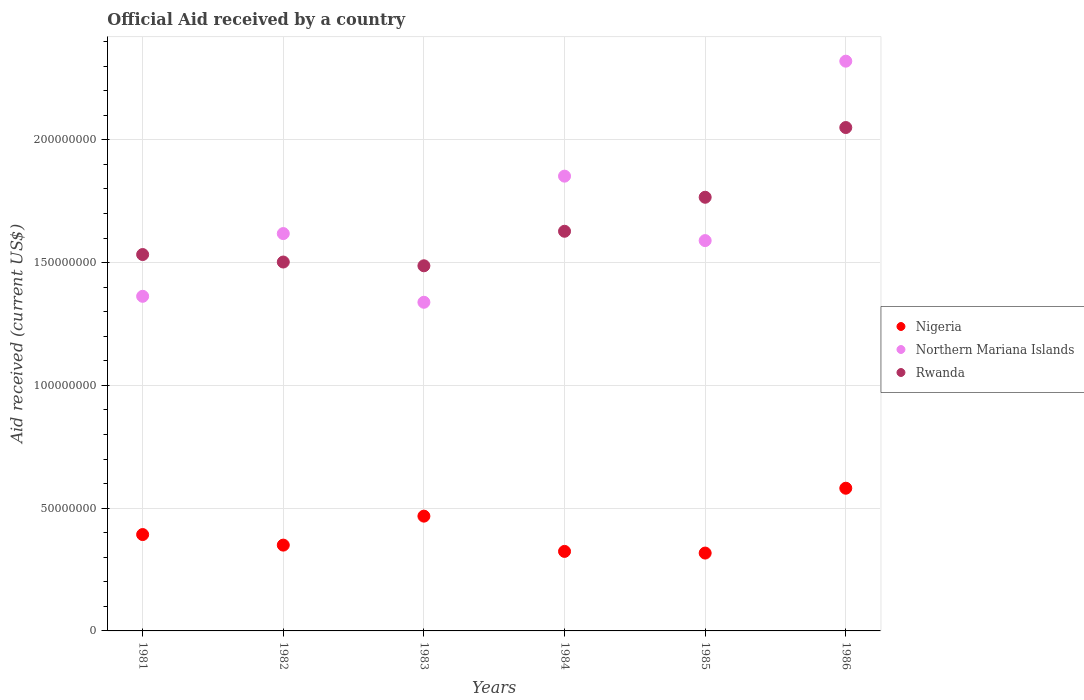Is the number of dotlines equal to the number of legend labels?
Your answer should be very brief. Yes. What is the net official aid received in Rwanda in 1985?
Ensure brevity in your answer.  1.77e+08. Across all years, what is the maximum net official aid received in Northern Mariana Islands?
Ensure brevity in your answer.  2.32e+08. Across all years, what is the minimum net official aid received in Northern Mariana Islands?
Your answer should be very brief. 1.34e+08. In which year was the net official aid received in Northern Mariana Islands minimum?
Your response must be concise. 1983. What is the total net official aid received in Nigeria in the graph?
Offer a terse response. 2.43e+08. What is the difference between the net official aid received in Northern Mariana Islands in 1982 and that in 1983?
Ensure brevity in your answer.  2.80e+07. What is the difference between the net official aid received in Nigeria in 1984 and the net official aid received in Rwanda in 1981?
Offer a terse response. -1.21e+08. What is the average net official aid received in Nigeria per year?
Give a very brief answer. 4.05e+07. In the year 1985, what is the difference between the net official aid received in Nigeria and net official aid received in Rwanda?
Your answer should be compact. -1.45e+08. What is the ratio of the net official aid received in Northern Mariana Islands in 1982 to that in 1983?
Give a very brief answer. 1.21. Is the net official aid received in Northern Mariana Islands in 1981 less than that in 1985?
Your response must be concise. Yes. Is the difference between the net official aid received in Nigeria in 1982 and 1984 greater than the difference between the net official aid received in Rwanda in 1982 and 1984?
Offer a very short reply. Yes. What is the difference between the highest and the second highest net official aid received in Rwanda?
Your response must be concise. 2.84e+07. What is the difference between the highest and the lowest net official aid received in Rwanda?
Keep it short and to the point. 5.63e+07. In how many years, is the net official aid received in Nigeria greater than the average net official aid received in Nigeria taken over all years?
Provide a short and direct response. 2. Is it the case that in every year, the sum of the net official aid received in Rwanda and net official aid received in Northern Mariana Islands  is greater than the net official aid received in Nigeria?
Keep it short and to the point. Yes. Does the net official aid received in Rwanda monotonically increase over the years?
Your answer should be very brief. No. Is the net official aid received in Nigeria strictly less than the net official aid received in Northern Mariana Islands over the years?
Provide a succinct answer. Yes. What is the difference between two consecutive major ticks on the Y-axis?
Offer a terse response. 5.00e+07. Does the graph contain any zero values?
Your answer should be very brief. No. Does the graph contain grids?
Keep it short and to the point. Yes. How many legend labels are there?
Provide a short and direct response. 3. What is the title of the graph?
Provide a succinct answer. Official Aid received by a country. Does "Dominica" appear as one of the legend labels in the graph?
Ensure brevity in your answer.  No. What is the label or title of the Y-axis?
Keep it short and to the point. Aid received (current US$). What is the Aid received (current US$) in Nigeria in 1981?
Make the answer very short. 3.92e+07. What is the Aid received (current US$) in Northern Mariana Islands in 1981?
Your answer should be very brief. 1.36e+08. What is the Aid received (current US$) in Rwanda in 1981?
Your answer should be compact. 1.53e+08. What is the Aid received (current US$) in Nigeria in 1982?
Give a very brief answer. 3.50e+07. What is the Aid received (current US$) of Northern Mariana Islands in 1982?
Offer a terse response. 1.62e+08. What is the Aid received (current US$) of Rwanda in 1982?
Your response must be concise. 1.50e+08. What is the Aid received (current US$) in Nigeria in 1983?
Offer a terse response. 4.68e+07. What is the Aid received (current US$) of Northern Mariana Islands in 1983?
Offer a very short reply. 1.34e+08. What is the Aid received (current US$) in Rwanda in 1983?
Offer a very short reply. 1.49e+08. What is the Aid received (current US$) in Nigeria in 1984?
Offer a terse response. 3.24e+07. What is the Aid received (current US$) in Northern Mariana Islands in 1984?
Ensure brevity in your answer.  1.85e+08. What is the Aid received (current US$) in Rwanda in 1984?
Your answer should be very brief. 1.63e+08. What is the Aid received (current US$) of Nigeria in 1985?
Your answer should be very brief. 3.17e+07. What is the Aid received (current US$) of Northern Mariana Islands in 1985?
Give a very brief answer. 1.59e+08. What is the Aid received (current US$) in Rwanda in 1985?
Your answer should be very brief. 1.77e+08. What is the Aid received (current US$) of Nigeria in 1986?
Your response must be concise. 5.81e+07. What is the Aid received (current US$) of Northern Mariana Islands in 1986?
Offer a terse response. 2.32e+08. What is the Aid received (current US$) in Rwanda in 1986?
Provide a succinct answer. 2.05e+08. Across all years, what is the maximum Aid received (current US$) in Nigeria?
Your response must be concise. 5.81e+07. Across all years, what is the maximum Aid received (current US$) of Northern Mariana Islands?
Offer a very short reply. 2.32e+08. Across all years, what is the maximum Aid received (current US$) in Rwanda?
Give a very brief answer. 2.05e+08. Across all years, what is the minimum Aid received (current US$) in Nigeria?
Give a very brief answer. 3.17e+07. Across all years, what is the minimum Aid received (current US$) of Northern Mariana Islands?
Ensure brevity in your answer.  1.34e+08. Across all years, what is the minimum Aid received (current US$) of Rwanda?
Your answer should be very brief. 1.49e+08. What is the total Aid received (current US$) of Nigeria in the graph?
Ensure brevity in your answer.  2.43e+08. What is the total Aid received (current US$) of Northern Mariana Islands in the graph?
Provide a succinct answer. 1.01e+09. What is the total Aid received (current US$) in Rwanda in the graph?
Provide a short and direct response. 9.97e+08. What is the difference between the Aid received (current US$) in Nigeria in 1981 and that in 1982?
Your answer should be very brief. 4.30e+06. What is the difference between the Aid received (current US$) of Northern Mariana Islands in 1981 and that in 1982?
Your answer should be compact. -2.56e+07. What is the difference between the Aid received (current US$) of Rwanda in 1981 and that in 1982?
Your response must be concise. 3.05e+06. What is the difference between the Aid received (current US$) in Nigeria in 1981 and that in 1983?
Your answer should be very brief. -7.50e+06. What is the difference between the Aid received (current US$) in Northern Mariana Islands in 1981 and that in 1983?
Offer a very short reply. 2.43e+06. What is the difference between the Aid received (current US$) of Rwanda in 1981 and that in 1983?
Ensure brevity in your answer.  4.58e+06. What is the difference between the Aid received (current US$) of Nigeria in 1981 and that in 1984?
Provide a succinct answer. 6.86e+06. What is the difference between the Aid received (current US$) in Northern Mariana Islands in 1981 and that in 1984?
Make the answer very short. -4.89e+07. What is the difference between the Aid received (current US$) in Rwanda in 1981 and that in 1984?
Your answer should be very brief. -9.48e+06. What is the difference between the Aid received (current US$) of Nigeria in 1981 and that in 1985?
Offer a terse response. 7.54e+06. What is the difference between the Aid received (current US$) in Northern Mariana Islands in 1981 and that in 1985?
Provide a short and direct response. -2.27e+07. What is the difference between the Aid received (current US$) in Rwanda in 1981 and that in 1985?
Offer a terse response. -2.33e+07. What is the difference between the Aid received (current US$) of Nigeria in 1981 and that in 1986?
Ensure brevity in your answer.  -1.89e+07. What is the difference between the Aid received (current US$) of Northern Mariana Islands in 1981 and that in 1986?
Provide a succinct answer. -9.58e+07. What is the difference between the Aid received (current US$) of Rwanda in 1981 and that in 1986?
Provide a succinct answer. -5.17e+07. What is the difference between the Aid received (current US$) of Nigeria in 1982 and that in 1983?
Your answer should be very brief. -1.18e+07. What is the difference between the Aid received (current US$) in Northern Mariana Islands in 1982 and that in 1983?
Give a very brief answer. 2.80e+07. What is the difference between the Aid received (current US$) of Rwanda in 1982 and that in 1983?
Provide a short and direct response. 1.53e+06. What is the difference between the Aid received (current US$) of Nigeria in 1982 and that in 1984?
Give a very brief answer. 2.56e+06. What is the difference between the Aid received (current US$) of Northern Mariana Islands in 1982 and that in 1984?
Make the answer very short. -2.34e+07. What is the difference between the Aid received (current US$) of Rwanda in 1982 and that in 1984?
Your response must be concise. -1.25e+07. What is the difference between the Aid received (current US$) in Nigeria in 1982 and that in 1985?
Keep it short and to the point. 3.24e+06. What is the difference between the Aid received (current US$) of Northern Mariana Islands in 1982 and that in 1985?
Offer a terse response. 2.86e+06. What is the difference between the Aid received (current US$) of Rwanda in 1982 and that in 1985?
Provide a succinct answer. -2.64e+07. What is the difference between the Aid received (current US$) in Nigeria in 1982 and that in 1986?
Provide a short and direct response. -2.32e+07. What is the difference between the Aid received (current US$) in Northern Mariana Islands in 1982 and that in 1986?
Provide a short and direct response. -7.02e+07. What is the difference between the Aid received (current US$) in Rwanda in 1982 and that in 1986?
Offer a very short reply. -5.48e+07. What is the difference between the Aid received (current US$) of Nigeria in 1983 and that in 1984?
Keep it short and to the point. 1.44e+07. What is the difference between the Aid received (current US$) in Northern Mariana Islands in 1983 and that in 1984?
Offer a terse response. -5.14e+07. What is the difference between the Aid received (current US$) in Rwanda in 1983 and that in 1984?
Offer a very short reply. -1.41e+07. What is the difference between the Aid received (current US$) of Nigeria in 1983 and that in 1985?
Your response must be concise. 1.50e+07. What is the difference between the Aid received (current US$) of Northern Mariana Islands in 1983 and that in 1985?
Your answer should be very brief. -2.51e+07. What is the difference between the Aid received (current US$) of Rwanda in 1983 and that in 1985?
Provide a short and direct response. -2.79e+07. What is the difference between the Aid received (current US$) of Nigeria in 1983 and that in 1986?
Keep it short and to the point. -1.14e+07. What is the difference between the Aid received (current US$) of Northern Mariana Islands in 1983 and that in 1986?
Give a very brief answer. -9.82e+07. What is the difference between the Aid received (current US$) in Rwanda in 1983 and that in 1986?
Your answer should be very brief. -5.63e+07. What is the difference between the Aid received (current US$) in Nigeria in 1984 and that in 1985?
Offer a terse response. 6.80e+05. What is the difference between the Aid received (current US$) of Northern Mariana Islands in 1984 and that in 1985?
Your response must be concise. 2.62e+07. What is the difference between the Aid received (current US$) of Rwanda in 1984 and that in 1985?
Give a very brief answer. -1.38e+07. What is the difference between the Aid received (current US$) of Nigeria in 1984 and that in 1986?
Your response must be concise. -2.57e+07. What is the difference between the Aid received (current US$) in Northern Mariana Islands in 1984 and that in 1986?
Provide a short and direct response. -4.68e+07. What is the difference between the Aid received (current US$) in Rwanda in 1984 and that in 1986?
Your answer should be very brief. -4.22e+07. What is the difference between the Aid received (current US$) in Nigeria in 1985 and that in 1986?
Give a very brief answer. -2.64e+07. What is the difference between the Aid received (current US$) in Northern Mariana Islands in 1985 and that in 1986?
Give a very brief answer. -7.31e+07. What is the difference between the Aid received (current US$) in Rwanda in 1985 and that in 1986?
Provide a succinct answer. -2.84e+07. What is the difference between the Aid received (current US$) of Nigeria in 1981 and the Aid received (current US$) of Northern Mariana Islands in 1982?
Ensure brevity in your answer.  -1.23e+08. What is the difference between the Aid received (current US$) of Nigeria in 1981 and the Aid received (current US$) of Rwanda in 1982?
Offer a very short reply. -1.11e+08. What is the difference between the Aid received (current US$) of Northern Mariana Islands in 1981 and the Aid received (current US$) of Rwanda in 1982?
Make the answer very short. -1.40e+07. What is the difference between the Aid received (current US$) in Nigeria in 1981 and the Aid received (current US$) in Northern Mariana Islands in 1983?
Ensure brevity in your answer.  -9.46e+07. What is the difference between the Aid received (current US$) in Nigeria in 1981 and the Aid received (current US$) in Rwanda in 1983?
Make the answer very short. -1.09e+08. What is the difference between the Aid received (current US$) of Northern Mariana Islands in 1981 and the Aid received (current US$) of Rwanda in 1983?
Offer a very short reply. -1.24e+07. What is the difference between the Aid received (current US$) in Nigeria in 1981 and the Aid received (current US$) in Northern Mariana Islands in 1984?
Provide a succinct answer. -1.46e+08. What is the difference between the Aid received (current US$) in Nigeria in 1981 and the Aid received (current US$) in Rwanda in 1984?
Provide a short and direct response. -1.24e+08. What is the difference between the Aid received (current US$) of Northern Mariana Islands in 1981 and the Aid received (current US$) of Rwanda in 1984?
Your answer should be compact. -2.65e+07. What is the difference between the Aid received (current US$) in Nigeria in 1981 and the Aid received (current US$) in Northern Mariana Islands in 1985?
Your answer should be compact. -1.20e+08. What is the difference between the Aid received (current US$) of Nigeria in 1981 and the Aid received (current US$) of Rwanda in 1985?
Ensure brevity in your answer.  -1.37e+08. What is the difference between the Aid received (current US$) in Northern Mariana Islands in 1981 and the Aid received (current US$) in Rwanda in 1985?
Keep it short and to the point. -4.03e+07. What is the difference between the Aid received (current US$) of Nigeria in 1981 and the Aid received (current US$) of Northern Mariana Islands in 1986?
Give a very brief answer. -1.93e+08. What is the difference between the Aid received (current US$) of Nigeria in 1981 and the Aid received (current US$) of Rwanda in 1986?
Your answer should be compact. -1.66e+08. What is the difference between the Aid received (current US$) in Northern Mariana Islands in 1981 and the Aid received (current US$) in Rwanda in 1986?
Your answer should be very brief. -6.87e+07. What is the difference between the Aid received (current US$) of Nigeria in 1982 and the Aid received (current US$) of Northern Mariana Islands in 1983?
Your answer should be very brief. -9.89e+07. What is the difference between the Aid received (current US$) of Nigeria in 1982 and the Aid received (current US$) of Rwanda in 1983?
Offer a very short reply. -1.14e+08. What is the difference between the Aid received (current US$) in Northern Mariana Islands in 1982 and the Aid received (current US$) in Rwanda in 1983?
Provide a short and direct response. 1.31e+07. What is the difference between the Aid received (current US$) of Nigeria in 1982 and the Aid received (current US$) of Northern Mariana Islands in 1984?
Keep it short and to the point. -1.50e+08. What is the difference between the Aid received (current US$) in Nigeria in 1982 and the Aid received (current US$) in Rwanda in 1984?
Offer a very short reply. -1.28e+08. What is the difference between the Aid received (current US$) in Northern Mariana Islands in 1982 and the Aid received (current US$) in Rwanda in 1984?
Give a very brief answer. -9.40e+05. What is the difference between the Aid received (current US$) in Nigeria in 1982 and the Aid received (current US$) in Northern Mariana Islands in 1985?
Offer a very short reply. -1.24e+08. What is the difference between the Aid received (current US$) in Nigeria in 1982 and the Aid received (current US$) in Rwanda in 1985?
Give a very brief answer. -1.42e+08. What is the difference between the Aid received (current US$) of Northern Mariana Islands in 1982 and the Aid received (current US$) of Rwanda in 1985?
Your answer should be compact. -1.48e+07. What is the difference between the Aid received (current US$) in Nigeria in 1982 and the Aid received (current US$) in Northern Mariana Islands in 1986?
Offer a terse response. -1.97e+08. What is the difference between the Aid received (current US$) of Nigeria in 1982 and the Aid received (current US$) of Rwanda in 1986?
Provide a succinct answer. -1.70e+08. What is the difference between the Aid received (current US$) of Northern Mariana Islands in 1982 and the Aid received (current US$) of Rwanda in 1986?
Your answer should be compact. -4.32e+07. What is the difference between the Aid received (current US$) in Nigeria in 1983 and the Aid received (current US$) in Northern Mariana Islands in 1984?
Your response must be concise. -1.38e+08. What is the difference between the Aid received (current US$) in Nigeria in 1983 and the Aid received (current US$) in Rwanda in 1984?
Provide a short and direct response. -1.16e+08. What is the difference between the Aid received (current US$) in Northern Mariana Islands in 1983 and the Aid received (current US$) in Rwanda in 1984?
Offer a very short reply. -2.89e+07. What is the difference between the Aid received (current US$) of Nigeria in 1983 and the Aid received (current US$) of Northern Mariana Islands in 1985?
Make the answer very short. -1.12e+08. What is the difference between the Aid received (current US$) of Nigeria in 1983 and the Aid received (current US$) of Rwanda in 1985?
Keep it short and to the point. -1.30e+08. What is the difference between the Aid received (current US$) of Northern Mariana Islands in 1983 and the Aid received (current US$) of Rwanda in 1985?
Your answer should be very brief. -4.28e+07. What is the difference between the Aid received (current US$) in Nigeria in 1983 and the Aid received (current US$) in Northern Mariana Islands in 1986?
Offer a terse response. -1.85e+08. What is the difference between the Aid received (current US$) in Nigeria in 1983 and the Aid received (current US$) in Rwanda in 1986?
Give a very brief answer. -1.58e+08. What is the difference between the Aid received (current US$) in Northern Mariana Islands in 1983 and the Aid received (current US$) in Rwanda in 1986?
Make the answer very short. -7.12e+07. What is the difference between the Aid received (current US$) in Nigeria in 1984 and the Aid received (current US$) in Northern Mariana Islands in 1985?
Provide a short and direct response. -1.27e+08. What is the difference between the Aid received (current US$) in Nigeria in 1984 and the Aid received (current US$) in Rwanda in 1985?
Give a very brief answer. -1.44e+08. What is the difference between the Aid received (current US$) of Northern Mariana Islands in 1984 and the Aid received (current US$) of Rwanda in 1985?
Provide a succinct answer. 8.60e+06. What is the difference between the Aid received (current US$) in Nigeria in 1984 and the Aid received (current US$) in Northern Mariana Islands in 1986?
Your response must be concise. -2.00e+08. What is the difference between the Aid received (current US$) of Nigeria in 1984 and the Aid received (current US$) of Rwanda in 1986?
Ensure brevity in your answer.  -1.73e+08. What is the difference between the Aid received (current US$) in Northern Mariana Islands in 1984 and the Aid received (current US$) in Rwanda in 1986?
Keep it short and to the point. -1.98e+07. What is the difference between the Aid received (current US$) of Nigeria in 1985 and the Aid received (current US$) of Northern Mariana Islands in 1986?
Your response must be concise. -2.00e+08. What is the difference between the Aid received (current US$) of Nigeria in 1985 and the Aid received (current US$) of Rwanda in 1986?
Offer a very short reply. -1.73e+08. What is the difference between the Aid received (current US$) in Northern Mariana Islands in 1985 and the Aid received (current US$) in Rwanda in 1986?
Your response must be concise. -4.60e+07. What is the average Aid received (current US$) in Nigeria per year?
Your answer should be very brief. 4.05e+07. What is the average Aid received (current US$) of Northern Mariana Islands per year?
Keep it short and to the point. 1.68e+08. What is the average Aid received (current US$) of Rwanda per year?
Ensure brevity in your answer.  1.66e+08. In the year 1981, what is the difference between the Aid received (current US$) in Nigeria and Aid received (current US$) in Northern Mariana Islands?
Offer a very short reply. -9.70e+07. In the year 1981, what is the difference between the Aid received (current US$) of Nigeria and Aid received (current US$) of Rwanda?
Ensure brevity in your answer.  -1.14e+08. In the year 1981, what is the difference between the Aid received (current US$) in Northern Mariana Islands and Aid received (current US$) in Rwanda?
Make the answer very short. -1.70e+07. In the year 1982, what is the difference between the Aid received (current US$) of Nigeria and Aid received (current US$) of Northern Mariana Islands?
Offer a terse response. -1.27e+08. In the year 1982, what is the difference between the Aid received (current US$) of Nigeria and Aid received (current US$) of Rwanda?
Your answer should be very brief. -1.15e+08. In the year 1982, what is the difference between the Aid received (current US$) of Northern Mariana Islands and Aid received (current US$) of Rwanda?
Your answer should be very brief. 1.16e+07. In the year 1983, what is the difference between the Aid received (current US$) of Nigeria and Aid received (current US$) of Northern Mariana Islands?
Ensure brevity in your answer.  -8.71e+07. In the year 1983, what is the difference between the Aid received (current US$) of Nigeria and Aid received (current US$) of Rwanda?
Your response must be concise. -1.02e+08. In the year 1983, what is the difference between the Aid received (current US$) in Northern Mariana Islands and Aid received (current US$) in Rwanda?
Keep it short and to the point. -1.49e+07. In the year 1984, what is the difference between the Aid received (current US$) in Nigeria and Aid received (current US$) in Northern Mariana Islands?
Offer a very short reply. -1.53e+08. In the year 1984, what is the difference between the Aid received (current US$) of Nigeria and Aid received (current US$) of Rwanda?
Provide a succinct answer. -1.30e+08. In the year 1984, what is the difference between the Aid received (current US$) in Northern Mariana Islands and Aid received (current US$) in Rwanda?
Keep it short and to the point. 2.24e+07. In the year 1985, what is the difference between the Aid received (current US$) in Nigeria and Aid received (current US$) in Northern Mariana Islands?
Provide a succinct answer. -1.27e+08. In the year 1985, what is the difference between the Aid received (current US$) in Nigeria and Aid received (current US$) in Rwanda?
Give a very brief answer. -1.45e+08. In the year 1985, what is the difference between the Aid received (current US$) in Northern Mariana Islands and Aid received (current US$) in Rwanda?
Your response must be concise. -1.76e+07. In the year 1986, what is the difference between the Aid received (current US$) of Nigeria and Aid received (current US$) of Northern Mariana Islands?
Ensure brevity in your answer.  -1.74e+08. In the year 1986, what is the difference between the Aid received (current US$) of Nigeria and Aid received (current US$) of Rwanda?
Offer a terse response. -1.47e+08. In the year 1986, what is the difference between the Aid received (current US$) in Northern Mariana Islands and Aid received (current US$) in Rwanda?
Keep it short and to the point. 2.70e+07. What is the ratio of the Aid received (current US$) of Nigeria in 1981 to that in 1982?
Make the answer very short. 1.12. What is the ratio of the Aid received (current US$) in Northern Mariana Islands in 1981 to that in 1982?
Ensure brevity in your answer.  0.84. What is the ratio of the Aid received (current US$) in Rwanda in 1981 to that in 1982?
Your answer should be compact. 1.02. What is the ratio of the Aid received (current US$) of Nigeria in 1981 to that in 1983?
Ensure brevity in your answer.  0.84. What is the ratio of the Aid received (current US$) of Northern Mariana Islands in 1981 to that in 1983?
Your response must be concise. 1.02. What is the ratio of the Aid received (current US$) of Rwanda in 1981 to that in 1983?
Keep it short and to the point. 1.03. What is the ratio of the Aid received (current US$) in Nigeria in 1981 to that in 1984?
Keep it short and to the point. 1.21. What is the ratio of the Aid received (current US$) of Northern Mariana Islands in 1981 to that in 1984?
Make the answer very short. 0.74. What is the ratio of the Aid received (current US$) of Rwanda in 1981 to that in 1984?
Make the answer very short. 0.94. What is the ratio of the Aid received (current US$) in Nigeria in 1981 to that in 1985?
Keep it short and to the point. 1.24. What is the ratio of the Aid received (current US$) of Northern Mariana Islands in 1981 to that in 1985?
Keep it short and to the point. 0.86. What is the ratio of the Aid received (current US$) in Rwanda in 1981 to that in 1985?
Ensure brevity in your answer.  0.87. What is the ratio of the Aid received (current US$) of Nigeria in 1981 to that in 1986?
Your answer should be compact. 0.68. What is the ratio of the Aid received (current US$) of Northern Mariana Islands in 1981 to that in 1986?
Provide a succinct answer. 0.59. What is the ratio of the Aid received (current US$) of Rwanda in 1981 to that in 1986?
Your answer should be very brief. 0.75. What is the ratio of the Aid received (current US$) in Nigeria in 1982 to that in 1983?
Provide a short and direct response. 0.75. What is the ratio of the Aid received (current US$) of Northern Mariana Islands in 1982 to that in 1983?
Give a very brief answer. 1.21. What is the ratio of the Aid received (current US$) in Rwanda in 1982 to that in 1983?
Your response must be concise. 1.01. What is the ratio of the Aid received (current US$) in Nigeria in 1982 to that in 1984?
Provide a short and direct response. 1.08. What is the ratio of the Aid received (current US$) of Northern Mariana Islands in 1982 to that in 1984?
Your answer should be compact. 0.87. What is the ratio of the Aid received (current US$) in Rwanda in 1982 to that in 1984?
Provide a short and direct response. 0.92. What is the ratio of the Aid received (current US$) in Nigeria in 1982 to that in 1985?
Your response must be concise. 1.1. What is the ratio of the Aid received (current US$) of Rwanda in 1982 to that in 1985?
Offer a terse response. 0.85. What is the ratio of the Aid received (current US$) of Nigeria in 1982 to that in 1986?
Your answer should be compact. 0.6. What is the ratio of the Aid received (current US$) in Northern Mariana Islands in 1982 to that in 1986?
Give a very brief answer. 0.7. What is the ratio of the Aid received (current US$) in Rwanda in 1982 to that in 1986?
Your response must be concise. 0.73. What is the ratio of the Aid received (current US$) in Nigeria in 1983 to that in 1984?
Make the answer very short. 1.44. What is the ratio of the Aid received (current US$) of Northern Mariana Islands in 1983 to that in 1984?
Offer a very short reply. 0.72. What is the ratio of the Aid received (current US$) of Rwanda in 1983 to that in 1984?
Your response must be concise. 0.91. What is the ratio of the Aid received (current US$) of Nigeria in 1983 to that in 1985?
Offer a very short reply. 1.47. What is the ratio of the Aid received (current US$) of Northern Mariana Islands in 1983 to that in 1985?
Offer a very short reply. 0.84. What is the ratio of the Aid received (current US$) in Rwanda in 1983 to that in 1985?
Make the answer very short. 0.84. What is the ratio of the Aid received (current US$) in Nigeria in 1983 to that in 1986?
Your response must be concise. 0.8. What is the ratio of the Aid received (current US$) in Northern Mariana Islands in 1983 to that in 1986?
Provide a succinct answer. 0.58. What is the ratio of the Aid received (current US$) of Rwanda in 1983 to that in 1986?
Your answer should be very brief. 0.73. What is the ratio of the Aid received (current US$) of Nigeria in 1984 to that in 1985?
Keep it short and to the point. 1.02. What is the ratio of the Aid received (current US$) of Northern Mariana Islands in 1984 to that in 1985?
Ensure brevity in your answer.  1.17. What is the ratio of the Aid received (current US$) in Rwanda in 1984 to that in 1985?
Ensure brevity in your answer.  0.92. What is the ratio of the Aid received (current US$) in Nigeria in 1984 to that in 1986?
Provide a succinct answer. 0.56. What is the ratio of the Aid received (current US$) of Northern Mariana Islands in 1984 to that in 1986?
Provide a succinct answer. 0.8. What is the ratio of the Aid received (current US$) of Rwanda in 1984 to that in 1986?
Your response must be concise. 0.79. What is the ratio of the Aid received (current US$) in Nigeria in 1985 to that in 1986?
Keep it short and to the point. 0.55. What is the ratio of the Aid received (current US$) in Northern Mariana Islands in 1985 to that in 1986?
Make the answer very short. 0.69. What is the ratio of the Aid received (current US$) in Rwanda in 1985 to that in 1986?
Your response must be concise. 0.86. What is the difference between the highest and the second highest Aid received (current US$) of Nigeria?
Provide a succinct answer. 1.14e+07. What is the difference between the highest and the second highest Aid received (current US$) of Northern Mariana Islands?
Ensure brevity in your answer.  4.68e+07. What is the difference between the highest and the second highest Aid received (current US$) in Rwanda?
Offer a very short reply. 2.84e+07. What is the difference between the highest and the lowest Aid received (current US$) in Nigeria?
Make the answer very short. 2.64e+07. What is the difference between the highest and the lowest Aid received (current US$) in Northern Mariana Islands?
Give a very brief answer. 9.82e+07. What is the difference between the highest and the lowest Aid received (current US$) of Rwanda?
Your response must be concise. 5.63e+07. 